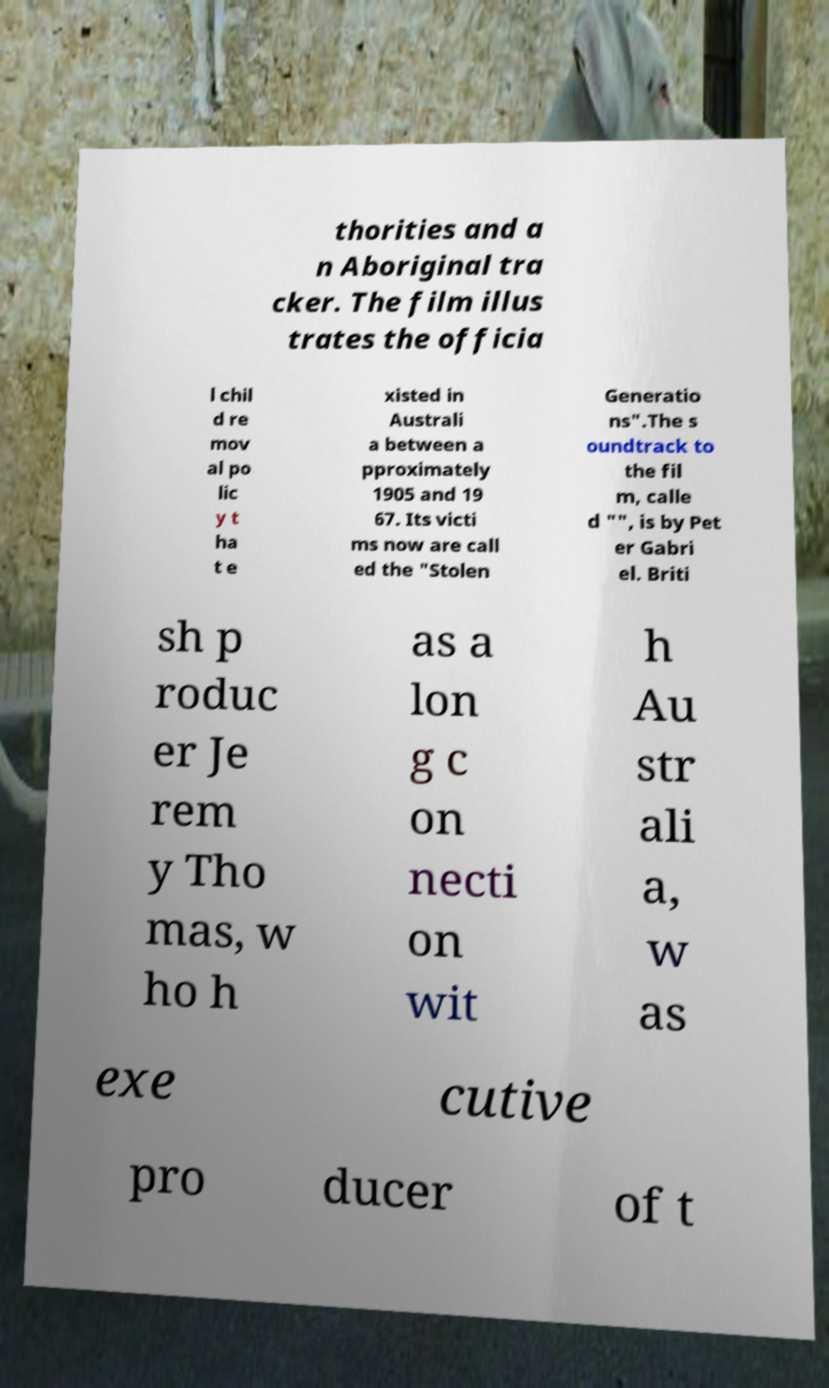Please read and relay the text visible in this image. What does it say? thorities and a n Aboriginal tra cker. The film illus trates the officia l chil d re mov al po lic y t ha t e xisted in Australi a between a pproximately 1905 and 19 67. Its victi ms now are call ed the "Stolen Generatio ns".The s oundtrack to the fil m, calle d "", is by Pet er Gabri el. Briti sh p roduc er Je rem y Tho mas, w ho h as a lon g c on necti on wit h Au str ali a, w as exe cutive pro ducer of t 